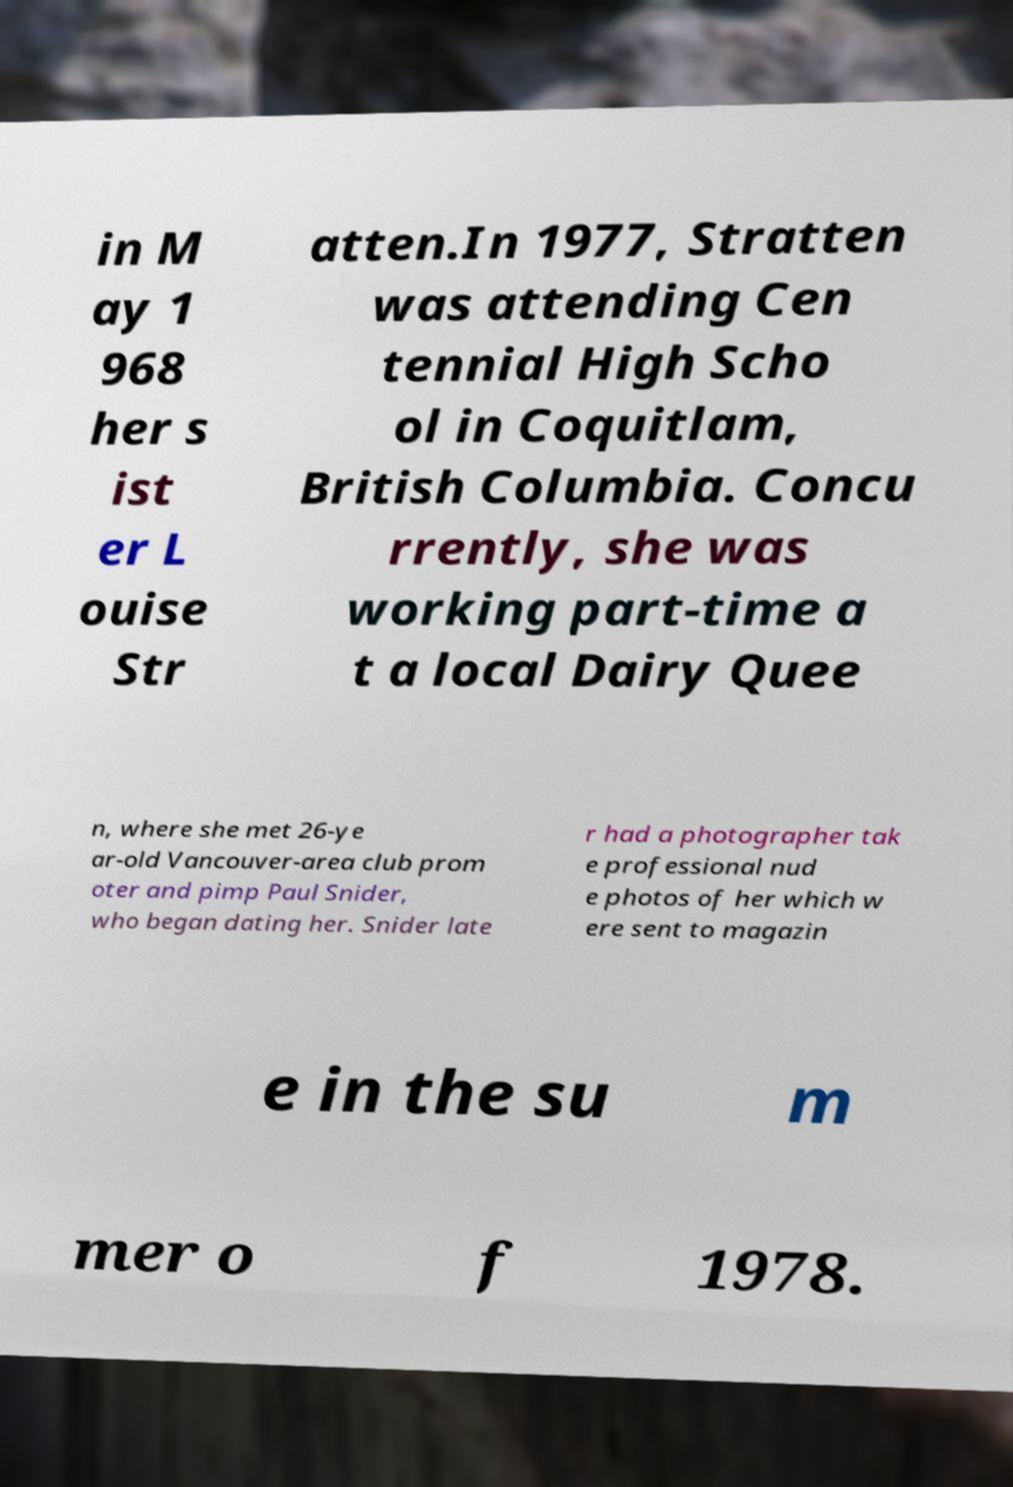Please read and relay the text visible in this image. What does it say? in M ay 1 968 her s ist er L ouise Str atten.In 1977, Stratten was attending Cen tennial High Scho ol in Coquitlam, British Columbia. Concu rrently, she was working part-time a t a local Dairy Quee n, where she met 26-ye ar-old Vancouver-area club prom oter and pimp Paul Snider, who began dating her. Snider late r had a photographer tak e professional nud e photos of her which w ere sent to magazin e in the su m mer o f 1978. 